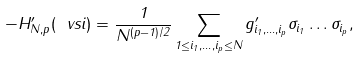Convert formula to latex. <formula><loc_0><loc_0><loc_500><loc_500>- H _ { N , p } ^ { \prime } ( \ v s i ) = \frac { 1 } { N ^ { ( p - 1 ) / 2 } } \sum _ { 1 \leq i _ { 1 } , \dots , i _ { p } \leq N } g _ { i _ { 1 } , \dots , i _ { p } } ^ { \prime } \sigma _ { i _ { 1 } } \dots \sigma _ { i _ { p } } ,</formula> 